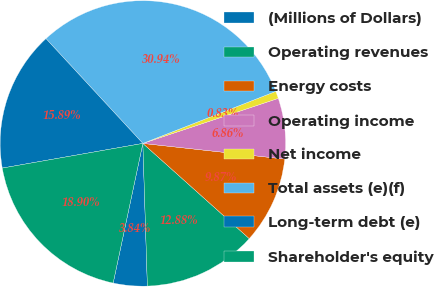Convert chart. <chart><loc_0><loc_0><loc_500><loc_500><pie_chart><fcel>(Millions of Dollars)<fcel>Operating revenues<fcel>Energy costs<fcel>Operating income<fcel>Net income<fcel>Total assets (e)(f)<fcel>Long-term debt (e)<fcel>Shareholder's equity<nl><fcel>3.84%<fcel>12.88%<fcel>9.87%<fcel>6.86%<fcel>0.83%<fcel>30.94%<fcel>15.89%<fcel>18.9%<nl></chart> 